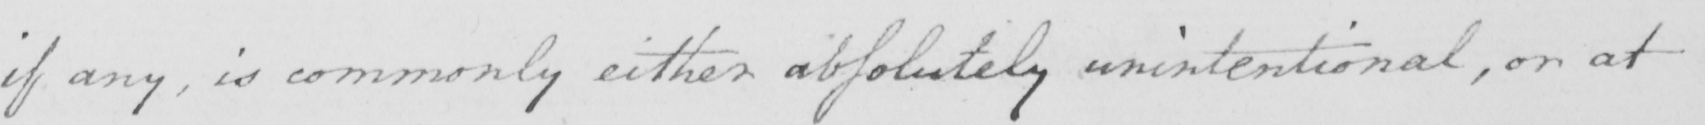Transcribe the text shown in this historical manuscript line. if any , is commonly either absolutely unintentional , or at 